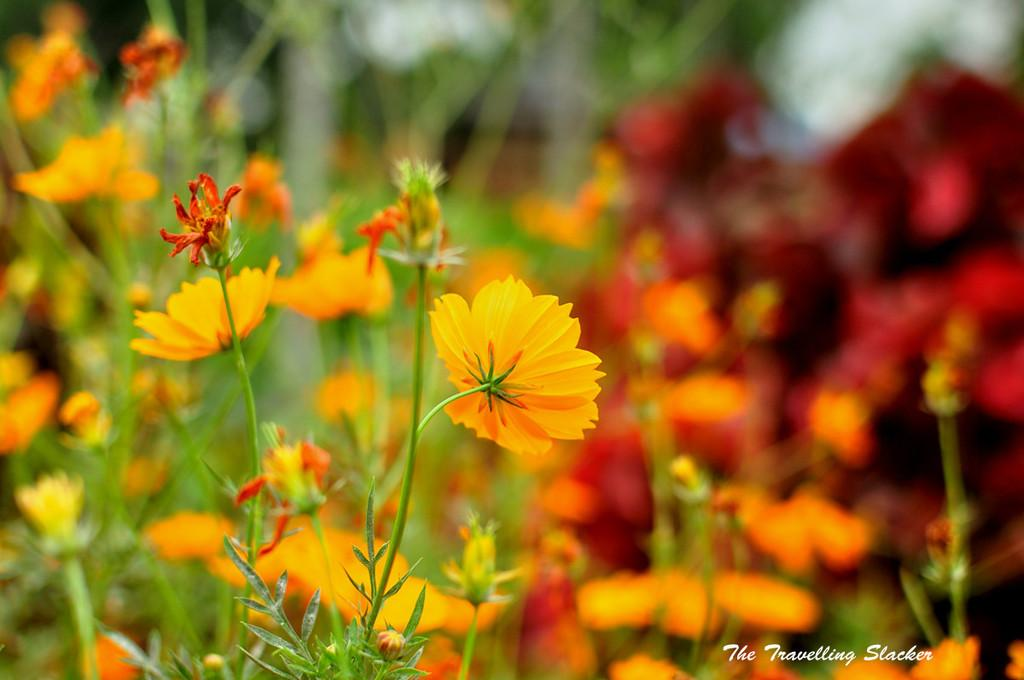What type of editing has been done to the image? The image is edited, but the specific type of editing is not mentioned in the facts. What can be seen in the image besides the editing? There are beautiful flower plants in the image, and one of them is highlighted. Where is the text located in the image? The text is in the bottom right corner of the image. What type of power source is used to light up the flower plants in the image? There is no mention of any power source or lighting in the image, as it features flower plants and text. 